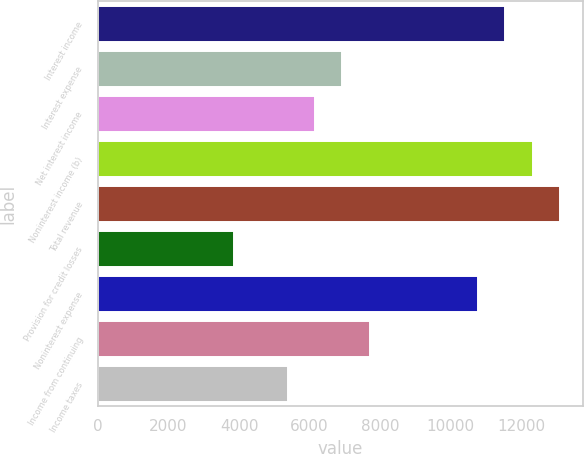Convert chart. <chart><loc_0><loc_0><loc_500><loc_500><bar_chart><fcel>Interest income<fcel>Interest expense<fcel>Net interest income<fcel>Noninterest income (b)<fcel>Total revenue<fcel>Provision for credit losses<fcel>Noninterest expense<fcel>Income from continuing<fcel>Income taxes<nl><fcel>11557.3<fcel>6934.56<fcel>6164.1<fcel>12327.8<fcel>13098.2<fcel>3852.72<fcel>10786.9<fcel>7705.02<fcel>5393.64<nl></chart> 